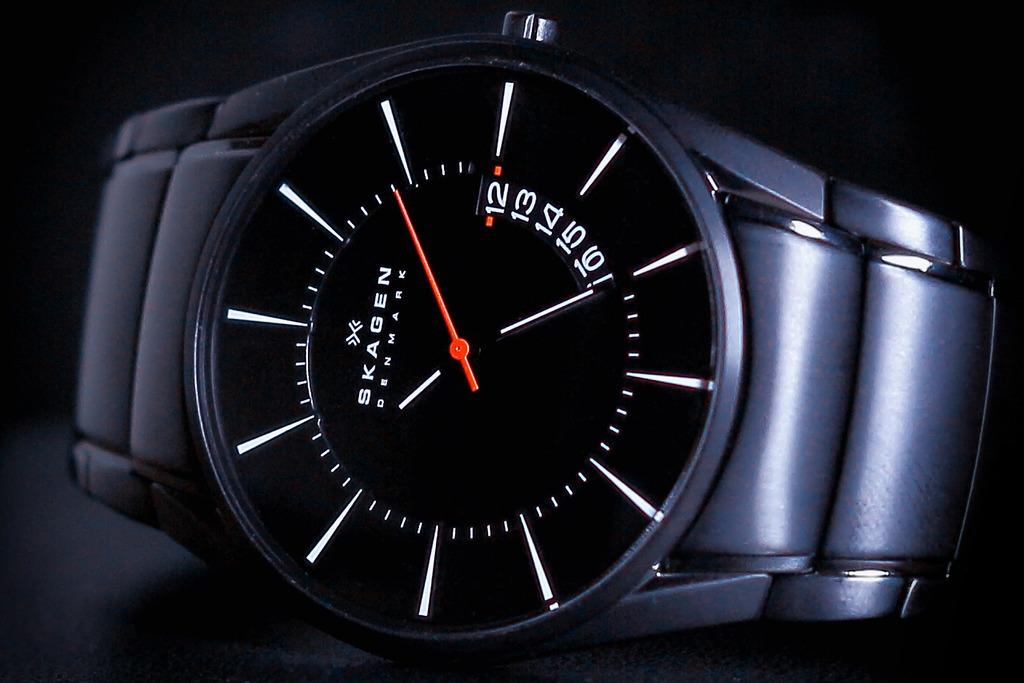<image>
Share a concise interpretation of the image provided. A black Skagen Denmark wrist watch is displayed against a black backdrop. 